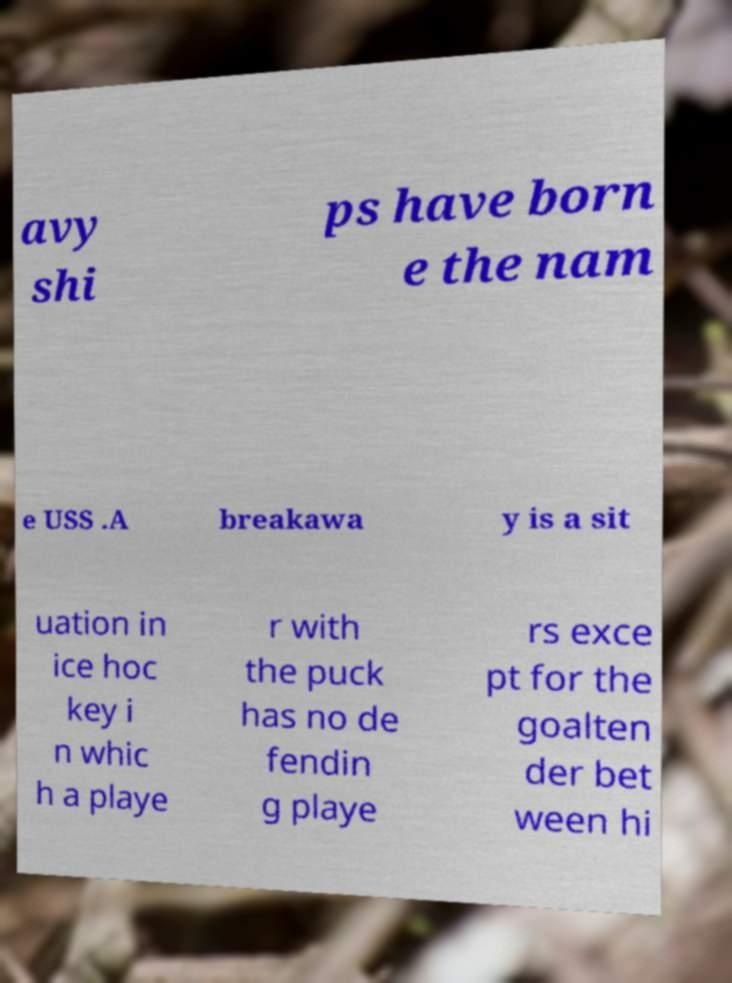Could you extract and type out the text from this image? avy shi ps have born e the nam e USS .A breakawa y is a sit uation in ice hoc key i n whic h a playe r with the puck has no de fendin g playe rs exce pt for the goalten der bet ween hi 